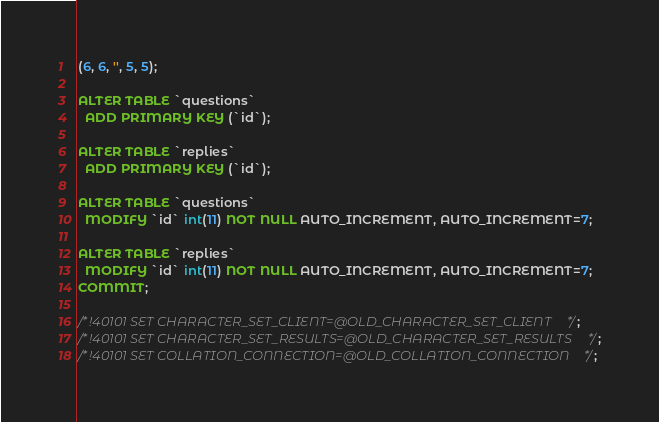<code> <loc_0><loc_0><loc_500><loc_500><_SQL_>(6, 6, '', 5, 5);

ALTER TABLE `questions`
  ADD PRIMARY KEY (`id`);

ALTER TABLE `replies`
  ADD PRIMARY KEY (`id`);

ALTER TABLE `questions`
  MODIFY `id` int(11) NOT NULL AUTO_INCREMENT, AUTO_INCREMENT=7;

ALTER TABLE `replies`
  MODIFY `id` int(11) NOT NULL AUTO_INCREMENT, AUTO_INCREMENT=7;
COMMIT;

/*!40101 SET CHARACTER_SET_CLIENT=@OLD_CHARACTER_SET_CLIENT */;
/*!40101 SET CHARACTER_SET_RESULTS=@OLD_CHARACTER_SET_RESULTS */;
/*!40101 SET COLLATION_CONNECTION=@OLD_COLLATION_CONNECTION */;
</code> 